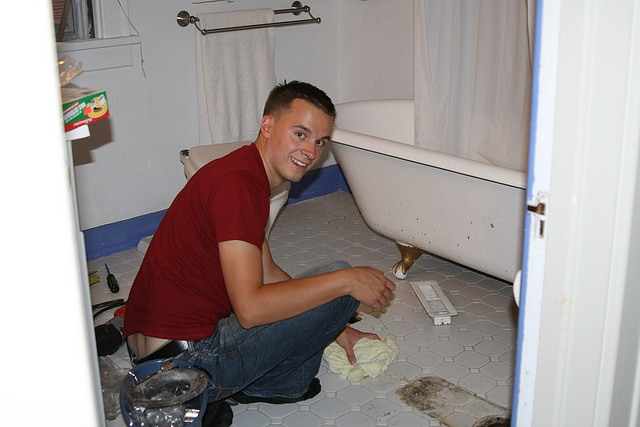Describe the objects in this image and their specific colors. I can see people in white, maroon, black, and brown tones and toilet in white, gray, and darkgray tones in this image. 